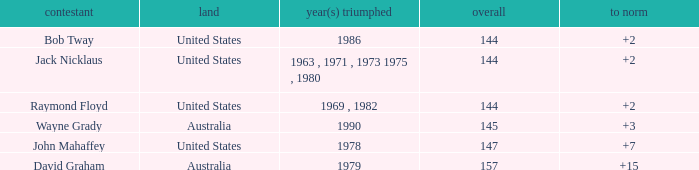What was the average round score of the player who won in 1978? 147.0. Could you parse the entire table as a dict? {'header': ['contestant', 'land', 'year(s) triumphed', 'overall', 'to norm'], 'rows': [['Bob Tway', 'United States', '1986', '144', '+2'], ['Jack Nicklaus', 'United States', '1963 , 1971 , 1973 1975 , 1980', '144', '+2'], ['Raymond Floyd', 'United States', '1969 , 1982', '144', '+2'], ['Wayne Grady', 'Australia', '1990', '145', '+3'], ['John Mahaffey', 'United States', '1978', '147', '+7'], ['David Graham', 'Australia', '1979', '157', '+15']]} 